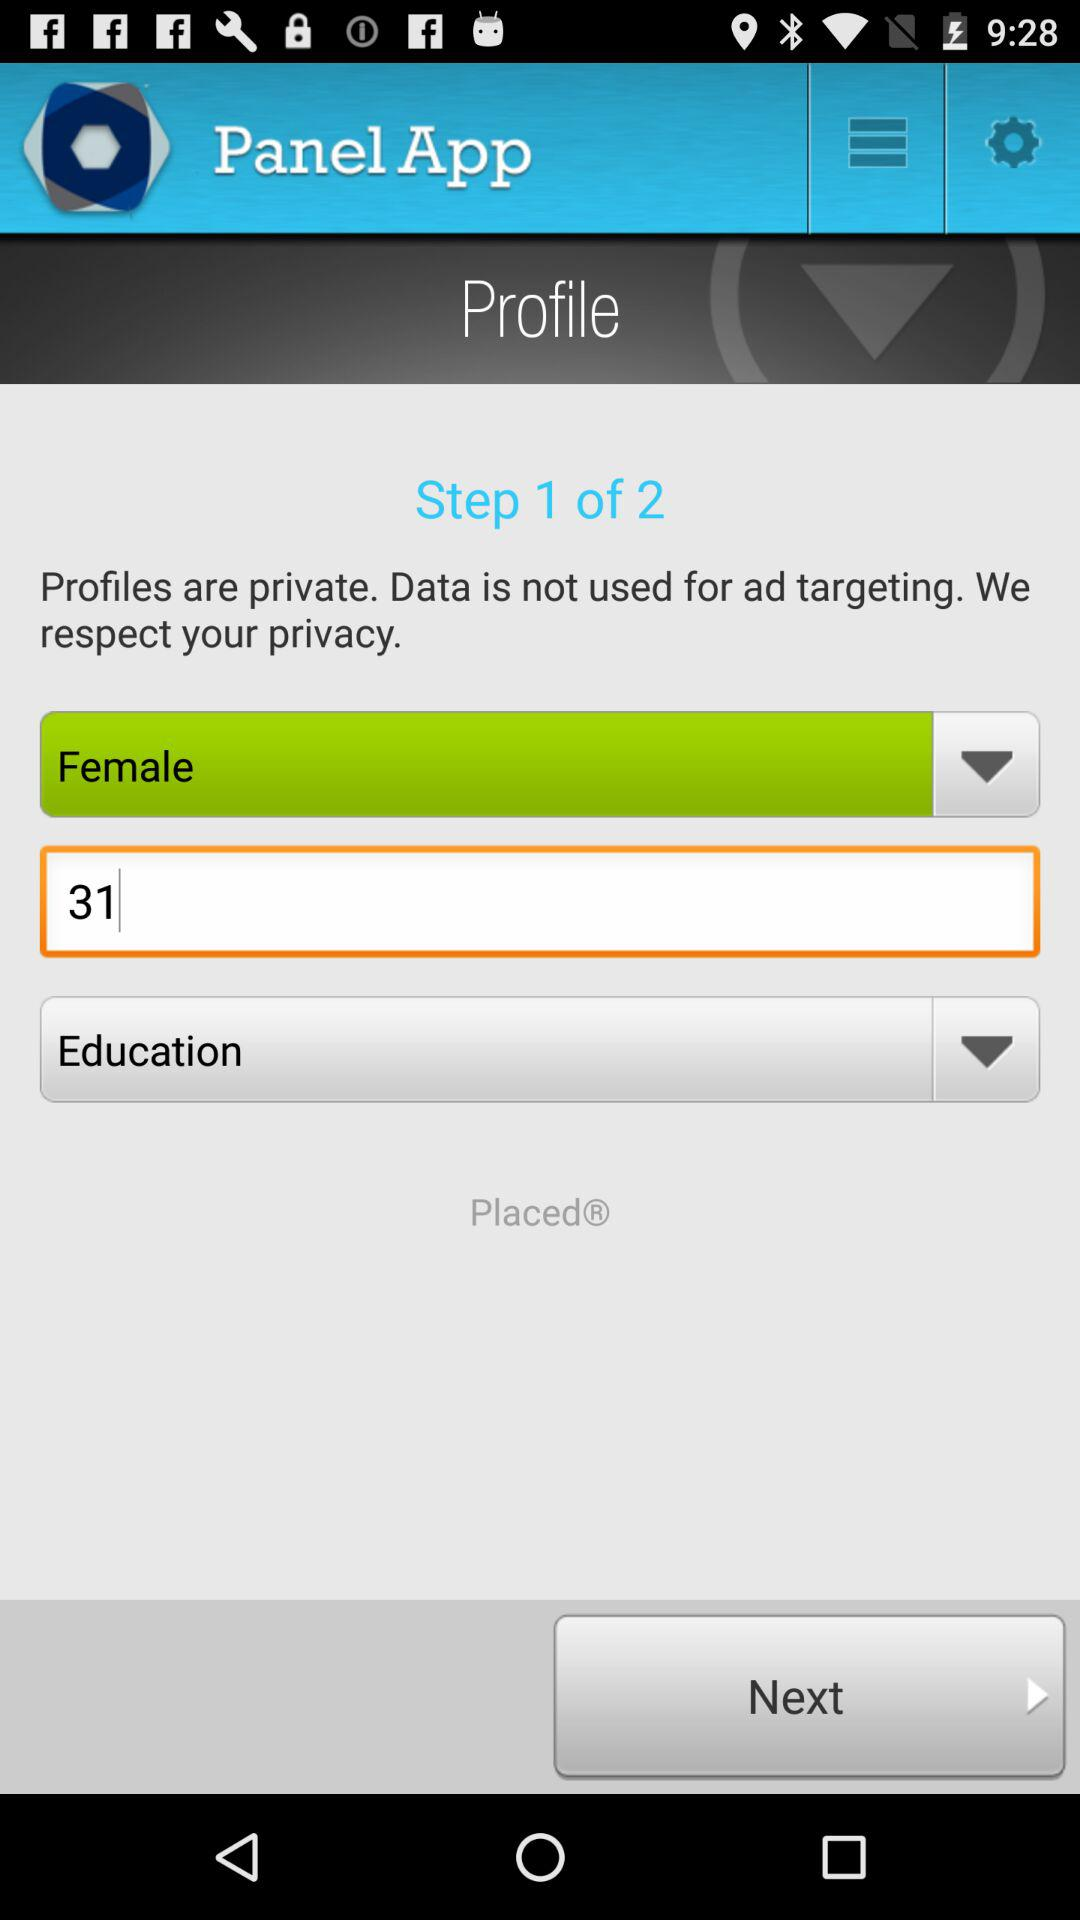What is the name of the application? The name of the application is "Panel App". 